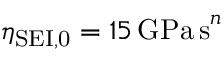<formula> <loc_0><loc_0><loc_500><loc_500>\eta _ { S E I , 0 } = 1 5 \, G P a \, s ^ { n }</formula> 